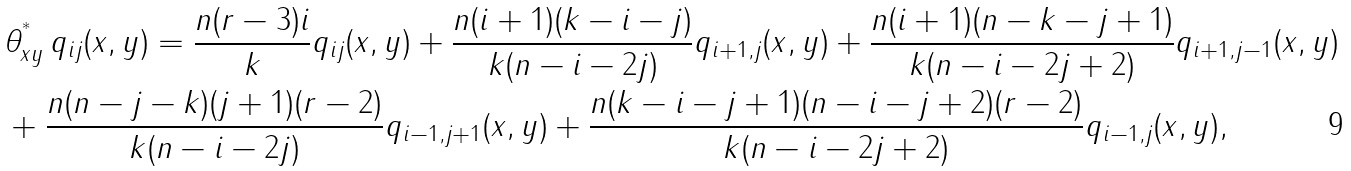<formula> <loc_0><loc_0><loc_500><loc_500>& \theta ^ { ^ { * } } _ { x y } \, q _ { i j } ( x , y ) = \frac { n ( r - 3 ) i } { k } q _ { i j } ( x , y ) + \frac { n ( i + 1 ) ( k - i - j ) } { k ( n - i - 2 j ) } q _ { i + 1 , j } ( x , y ) + \frac { n ( i + 1 ) ( n - k - j + 1 ) } { k ( n - i - 2 j + 2 ) } q _ { i + 1 , j - 1 } ( x , y ) \\ & + \frac { n ( n - j - k ) ( j + 1 ) ( r - 2 ) } { k ( n - i - 2 j ) } q _ { i - 1 , j + 1 } ( x , y ) + \frac { n ( k - i - j + 1 ) ( n - i - j + 2 ) ( r - 2 ) } { k ( n - i - 2 j + 2 ) } q _ { i - 1 , j } ( x , y ) ,</formula> 